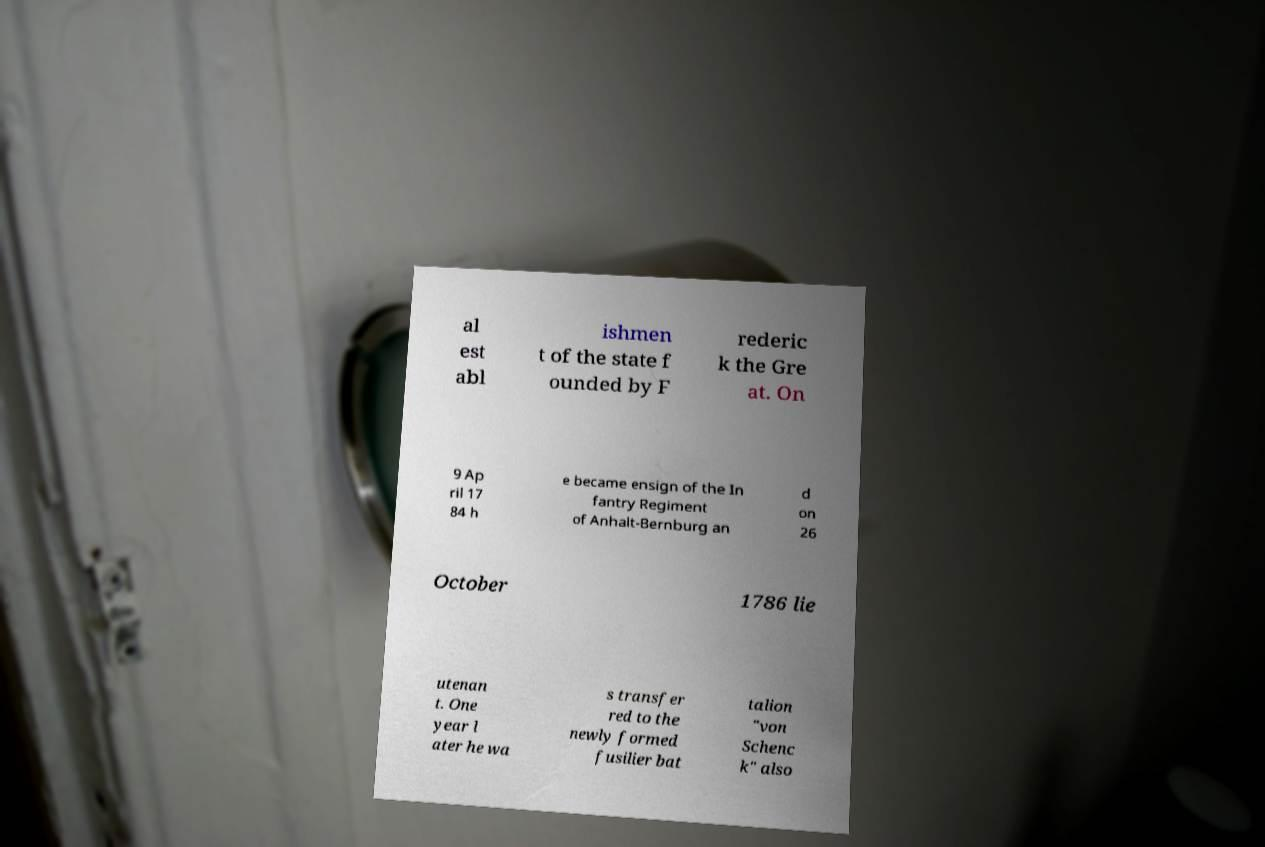Could you assist in decoding the text presented in this image and type it out clearly? al est abl ishmen t of the state f ounded by F rederic k the Gre at. On 9 Ap ril 17 84 h e became ensign of the In fantry Regiment of Anhalt-Bernburg an d on 26 October 1786 lie utenan t. One year l ater he wa s transfer red to the newly formed fusilier bat talion "von Schenc k" also 